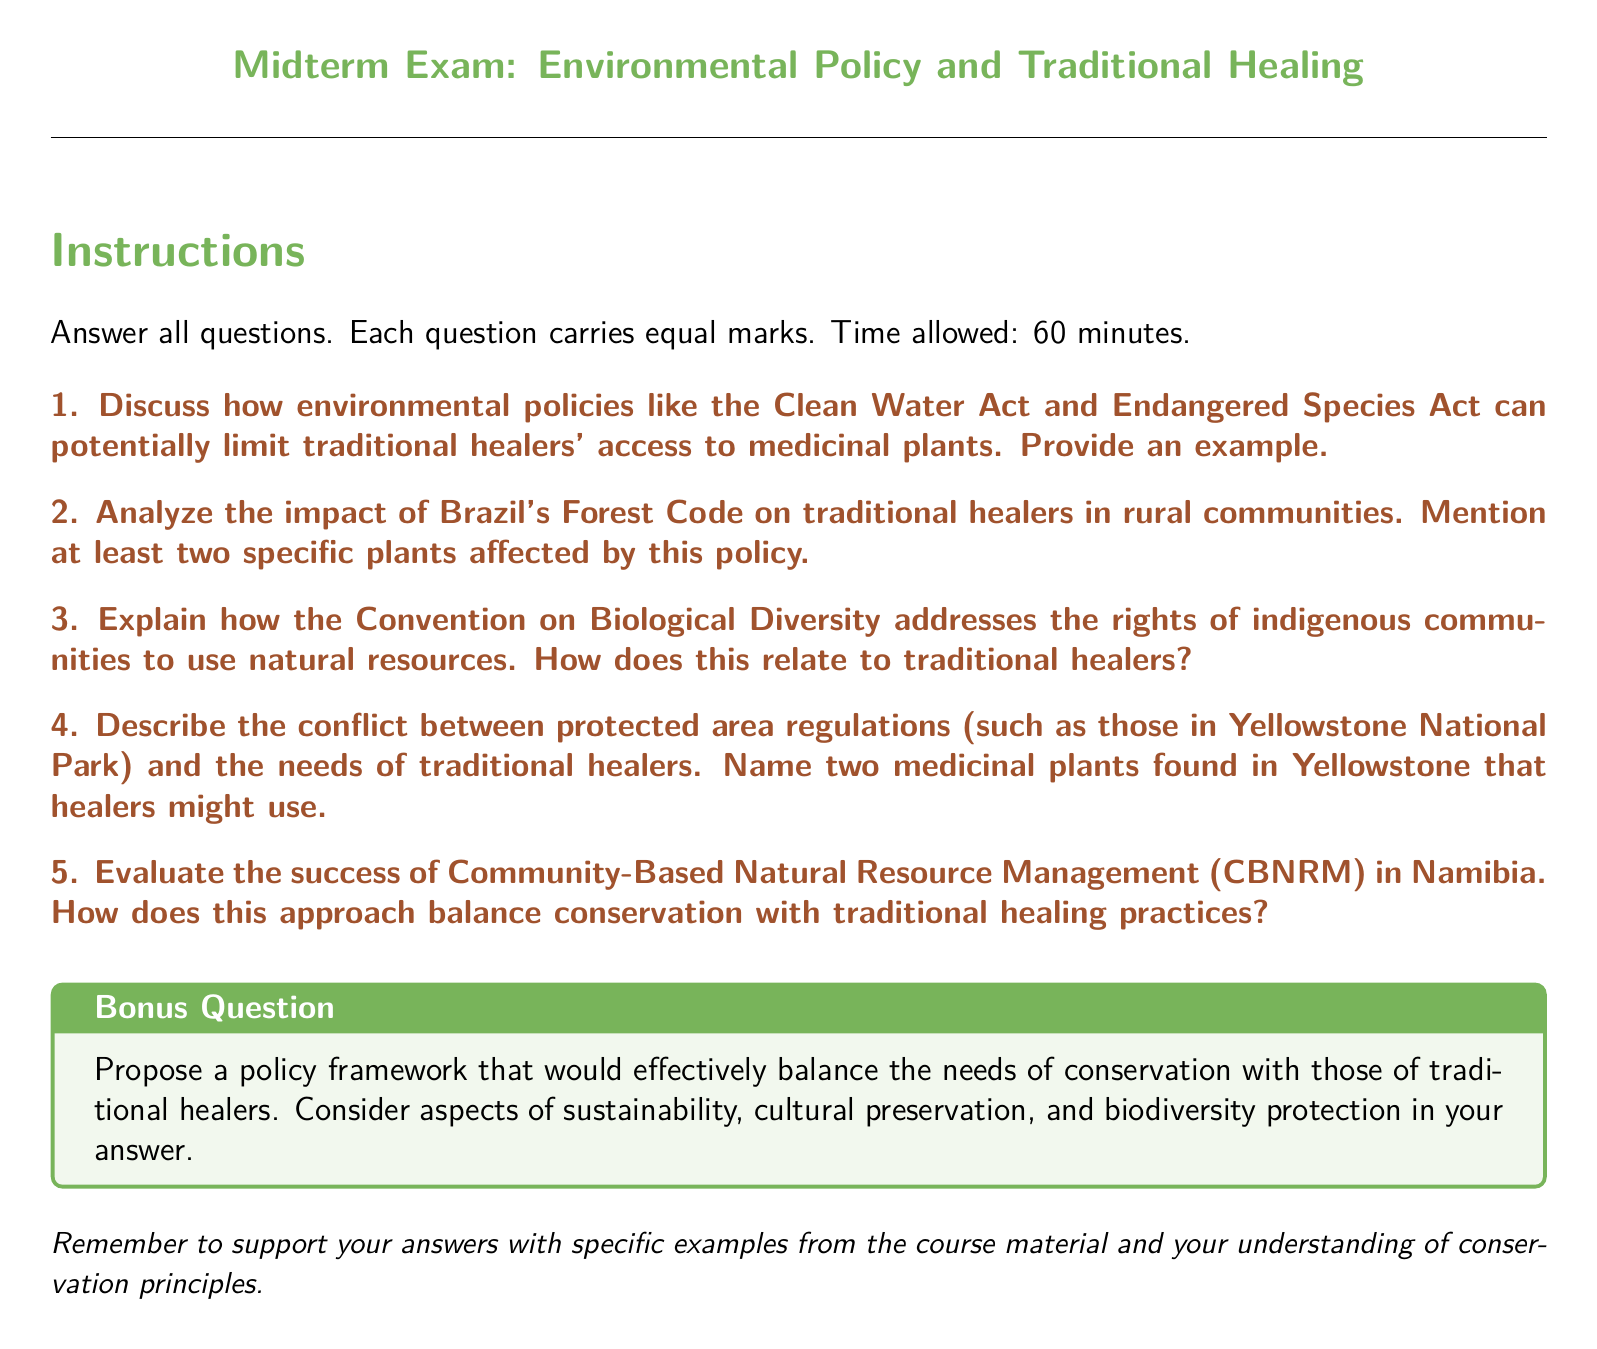What is the maximum time allowed for the exam? The maximum time allowed for the exam is specified in the instructions section of the document.
Answer: 60 minutes How many main questions are there in the exam? The number of main questions can be counted in the list following the instructions.
Answer: 5 What color is used for the title of the exam? The color used for the title is specified in the formatting commands near the beginning of the document.
Answer: Leaf green What is the title of the bonus question section? The title of the bonus question section is indicated in the tcolorbox command.
Answer: Bonus Question Name one of the acts discussed that could limit traditional healers' access to medicinal plants. This act is mentioned in the first exam question as a limiting environmental policy.
Answer: Clean Water Act What is one of the plants mentioned in the second exam question? The specific plants to be mentioned are indicated in the context of the second question regarding Brazil's Forest Code, prompting recall of specific examples.
Answer: (Any specific plant can be an answer, but it is not provided in the document. However, an example could be "Brazilian rosewood" which is known to be a targeted species in discussions about forestry policies.) What is a key aspect to consider in the proposed policy framework in the bonus question? The aspect mentioned is among the guiding principles listed in the bonus question prompt.
Answer: Sustainability What is the focus of the Community-Based Natural Resource Management evaluation in the fifth question? The focus is hinted at in the context of the question concerning the practice and its implications for various stakeholders.
Answer: Balance conservation with traditional healing practices 